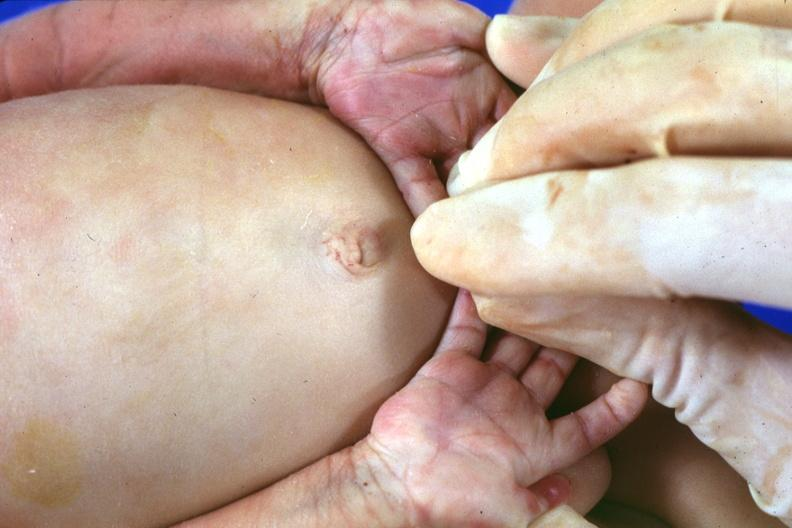what is present?
Answer the question using a single word or phrase. Hand 